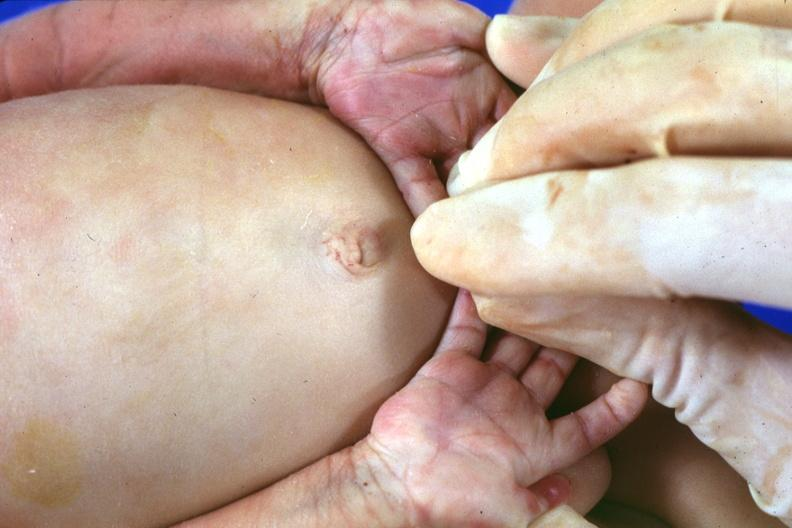what is present?
Answer the question using a single word or phrase. Hand 